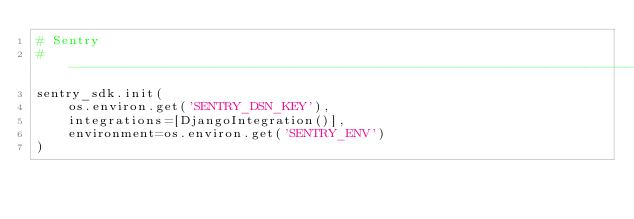<code> <loc_0><loc_0><loc_500><loc_500><_Python_># Sentry
# ---------------------------------------------------------------------------------------------------------------------
sentry_sdk.init(
    os.environ.get('SENTRY_DSN_KEY'),
    integrations=[DjangoIntegration()],
    environment=os.environ.get('SENTRY_ENV')
)
</code> 